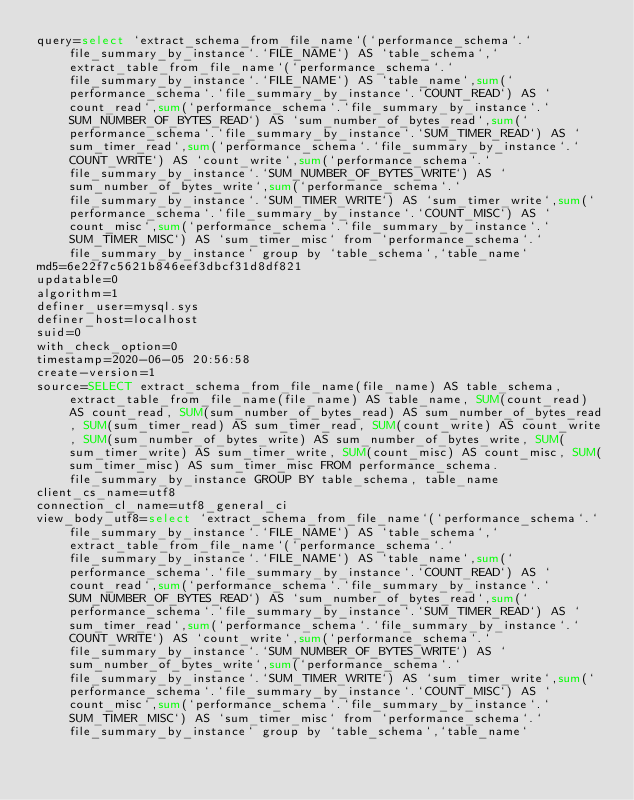Convert code to text. <code><loc_0><loc_0><loc_500><loc_500><_VisualBasic_>query=select `extract_schema_from_file_name`(`performance_schema`.`file_summary_by_instance`.`FILE_NAME`) AS `table_schema`,`extract_table_from_file_name`(`performance_schema`.`file_summary_by_instance`.`FILE_NAME`) AS `table_name`,sum(`performance_schema`.`file_summary_by_instance`.`COUNT_READ`) AS `count_read`,sum(`performance_schema`.`file_summary_by_instance`.`SUM_NUMBER_OF_BYTES_READ`) AS `sum_number_of_bytes_read`,sum(`performance_schema`.`file_summary_by_instance`.`SUM_TIMER_READ`) AS `sum_timer_read`,sum(`performance_schema`.`file_summary_by_instance`.`COUNT_WRITE`) AS `count_write`,sum(`performance_schema`.`file_summary_by_instance`.`SUM_NUMBER_OF_BYTES_WRITE`) AS `sum_number_of_bytes_write`,sum(`performance_schema`.`file_summary_by_instance`.`SUM_TIMER_WRITE`) AS `sum_timer_write`,sum(`performance_schema`.`file_summary_by_instance`.`COUNT_MISC`) AS `count_misc`,sum(`performance_schema`.`file_summary_by_instance`.`SUM_TIMER_MISC`) AS `sum_timer_misc` from `performance_schema`.`file_summary_by_instance` group by `table_schema`,`table_name`
md5=6e22f7c5621b846eef3dbcf31d8df821
updatable=0
algorithm=1
definer_user=mysql.sys
definer_host=localhost
suid=0
with_check_option=0
timestamp=2020-06-05 20:56:58
create-version=1
source=SELECT extract_schema_from_file_name(file_name) AS table_schema, extract_table_from_file_name(file_name) AS table_name, SUM(count_read) AS count_read, SUM(sum_number_of_bytes_read) AS sum_number_of_bytes_read, SUM(sum_timer_read) AS sum_timer_read, SUM(count_write) AS count_write, SUM(sum_number_of_bytes_write) AS sum_number_of_bytes_write, SUM(sum_timer_write) AS sum_timer_write, SUM(count_misc) AS count_misc, SUM(sum_timer_misc) AS sum_timer_misc FROM performance_schema.file_summary_by_instance GROUP BY table_schema, table_name
client_cs_name=utf8
connection_cl_name=utf8_general_ci
view_body_utf8=select `extract_schema_from_file_name`(`performance_schema`.`file_summary_by_instance`.`FILE_NAME`) AS `table_schema`,`extract_table_from_file_name`(`performance_schema`.`file_summary_by_instance`.`FILE_NAME`) AS `table_name`,sum(`performance_schema`.`file_summary_by_instance`.`COUNT_READ`) AS `count_read`,sum(`performance_schema`.`file_summary_by_instance`.`SUM_NUMBER_OF_BYTES_READ`) AS `sum_number_of_bytes_read`,sum(`performance_schema`.`file_summary_by_instance`.`SUM_TIMER_READ`) AS `sum_timer_read`,sum(`performance_schema`.`file_summary_by_instance`.`COUNT_WRITE`) AS `count_write`,sum(`performance_schema`.`file_summary_by_instance`.`SUM_NUMBER_OF_BYTES_WRITE`) AS `sum_number_of_bytes_write`,sum(`performance_schema`.`file_summary_by_instance`.`SUM_TIMER_WRITE`) AS `sum_timer_write`,sum(`performance_schema`.`file_summary_by_instance`.`COUNT_MISC`) AS `count_misc`,sum(`performance_schema`.`file_summary_by_instance`.`SUM_TIMER_MISC`) AS `sum_timer_misc` from `performance_schema`.`file_summary_by_instance` group by `table_schema`,`table_name`
</code> 